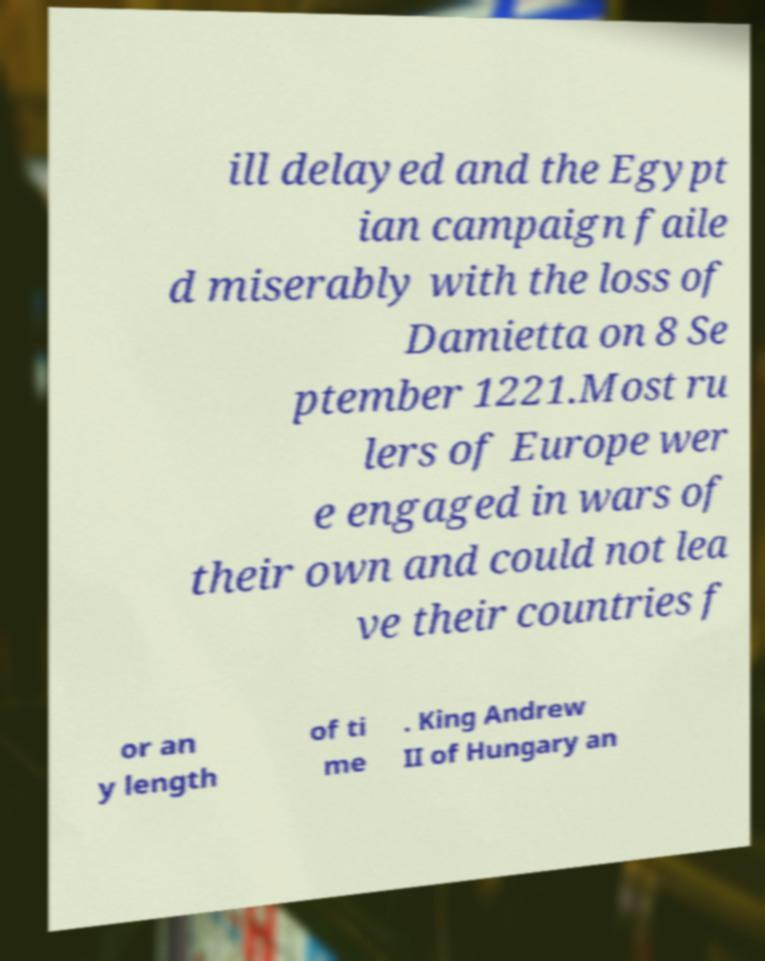There's text embedded in this image that I need extracted. Can you transcribe it verbatim? ill delayed and the Egypt ian campaign faile d miserably with the loss of Damietta on 8 Se ptember 1221.Most ru lers of Europe wer e engaged in wars of their own and could not lea ve their countries f or an y length of ti me . King Andrew II of Hungary an 